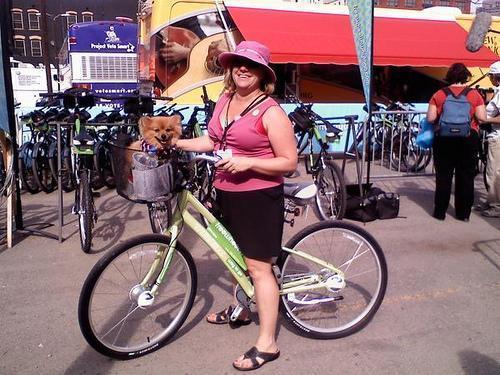How many tires does each bicycle have?
Give a very brief answer. 2. How many people are in the picture?
Give a very brief answer. 3. How many people are wearing backpacks?
Give a very brief answer. 1. How many tattoos does the woman have on her arm?
Give a very brief answer. 0. How many bicycles are in the photo?
Give a very brief answer. 3. How many people can you see?
Give a very brief answer. 2. How many elephants are there?
Give a very brief answer. 0. 